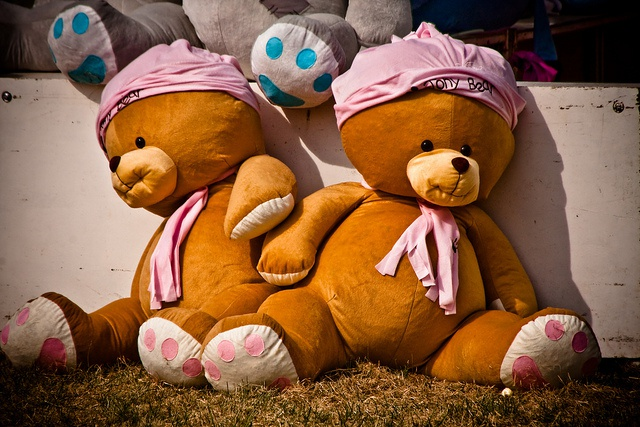Describe the objects in this image and their specific colors. I can see teddy bear in black, maroon, brown, and orange tones, teddy bear in black, brown, orange, maroon, and lightpink tones, and teddy bear in black, gray, and darkgray tones in this image. 